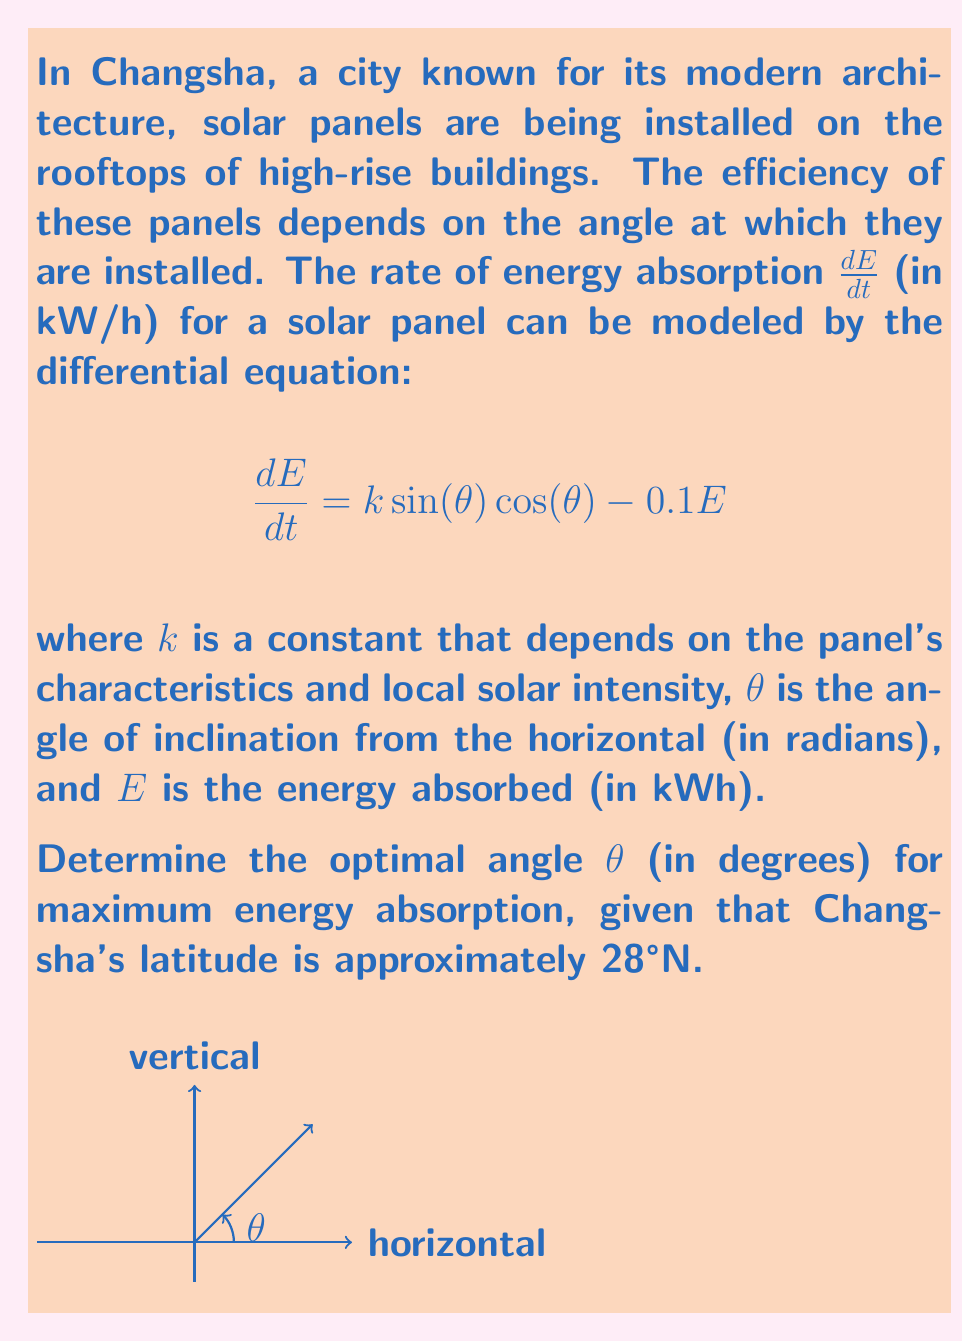Show me your answer to this math problem. Let's approach this step-by-step:

1) For maximum energy absorption, we need to find the angle $\theta$ that maximizes $\frac{dE}{dt}$. 

2) At equilibrium, $\frac{dE}{dt} = 0$, so:

   $$k \sin(\theta) \cos(\theta) - 0.1E = 0$$

3) The maximum energy absorption occurs when $\frac{d^2E}{dt^2} = 0$. Differentiating the original equation with respect to $\theta$:

   $$\frac{d^2E}{d\theta dt} = k(\cos^2(\theta) - \sin^2(\theta))$$

4) Setting this equal to zero:

   $$k(\cos^2(\theta) - \sin^2(\theta)) = 0$$
   $$\cos^2(\theta) = \sin^2(\theta)$$

5) This is true when $\cos(\theta) = \sin(\theta)$, which occurs when $\theta = 45°$.

6) However, this is the optimal angle for a location on the equator. For locations away from the equator, we need to adjust this angle based on the latitude.

7) A general rule of thumb is to add the latitude to this 45° angle for locations in the Northern Hemisphere.

8) Changsha's latitude is approximately 28°N, so the optimal angle would be:

   $$\theta_{optimal} = 45° + 28° = 73°$$

This angle ensures that the panels receive maximum direct sunlight throughout the year, accounting for the sun's position changes due to Changsha's latitude.
Answer: 73° 